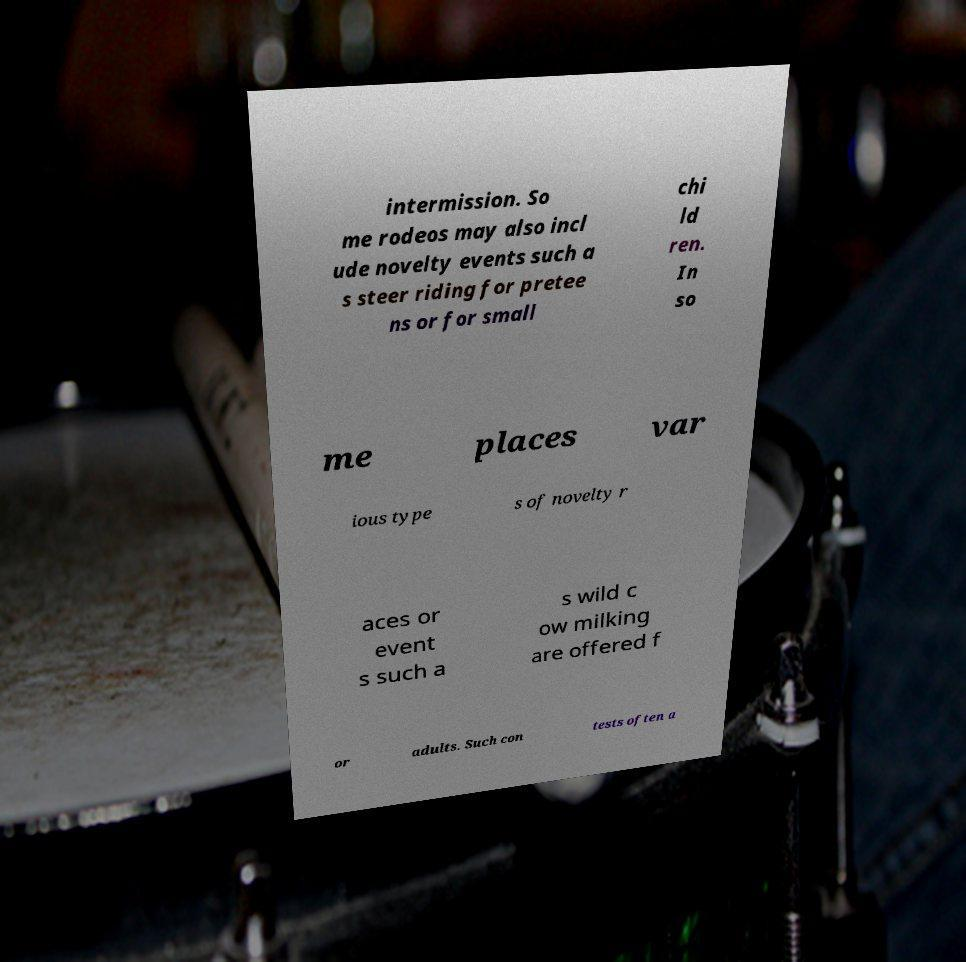Could you extract and type out the text from this image? intermission. So me rodeos may also incl ude novelty events such a s steer riding for pretee ns or for small chi ld ren. In so me places var ious type s of novelty r aces or event s such a s wild c ow milking are offered f or adults. Such con tests often a 